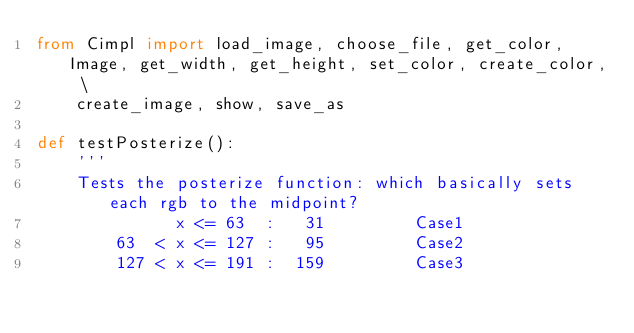Convert code to text. <code><loc_0><loc_0><loc_500><loc_500><_Python_>from Cimpl import load_image, choose_file, get_color, Image, get_width, get_height, set_color, create_color, \
    create_image, show, save_as

def testPosterize():
    '''
    Tests the posterize function: which basically sets each rgb to the midpoint?
              x <= 63  :   31         Case1
        63  < x <= 127 :   95         Case2
        127 < x <= 191 :  159         Case3</code> 